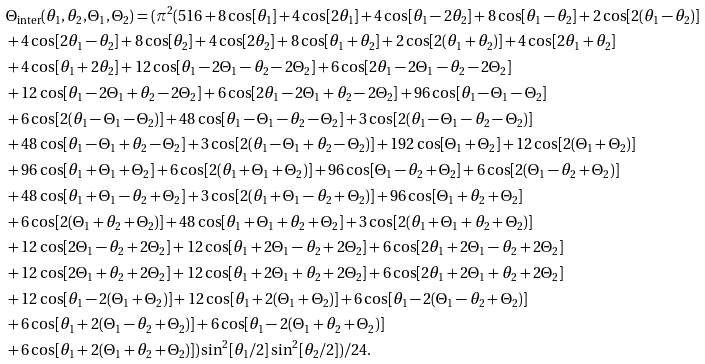Convert formula to latex. <formula><loc_0><loc_0><loc_500><loc_500>& { \Theta } _ { \text {inter} } ( \theta _ { 1 } , \theta _ { 2 } , \Theta _ { 1 } , \Theta _ { 2 } ) = ( \pi ^ { 2 } ( 5 1 6 + 8 \cos [ \theta _ { 1 } ] + 4 \cos [ 2 \theta _ { 1 } ] + 4 \cos [ \theta _ { 1 } - 2 \theta _ { 2 } ] + 8 \cos [ \theta _ { 1 } - \theta _ { 2 } ] + 2 \cos [ 2 ( \theta _ { 1 } - \theta _ { 2 } ) ] \\ & + 4 \cos [ 2 \theta _ { 1 } - \theta _ { 2 } ] + 8 \cos [ \theta _ { 2 } ] + 4 \cos [ 2 \theta _ { 2 } ] + 8 \cos [ \theta _ { 1 } + \theta _ { 2 } ] + 2 \cos [ 2 ( \theta _ { 1 } + \theta _ { 2 } ) ] + 4 \cos [ 2 \theta _ { 1 } + \theta _ { 2 } ] \\ & + 4 \cos [ \theta _ { 1 } + 2 \theta _ { 2 } ] + 1 2 \cos [ \theta _ { 1 } - 2 \Theta _ { 1 } - \theta _ { 2 } - 2 \Theta _ { 2 } ] + 6 \cos [ 2 \theta _ { 1 } - 2 \Theta _ { 1 } - \theta _ { 2 } - 2 \Theta _ { 2 } ] \\ & + 1 2 \cos [ \theta _ { 1 } - 2 \Theta _ { 1 } + \theta _ { 2 } - 2 \Theta _ { 2 } ] + 6 \cos [ 2 \theta _ { 1 } - 2 \Theta _ { 1 } + \theta _ { 2 } - 2 \Theta _ { 2 } ] + 9 6 \cos [ \theta _ { 1 } - \Theta _ { 1 } - \Theta _ { 2 } ] \\ & + 6 \cos [ 2 ( \theta _ { 1 } - \Theta _ { 1 } - \Theta _ { 2 } ) ] + 4 8 \cos [ \theta _ { 1 } - \Theta _ { 1 } - \theta _ { 2 } - \Theta _ { 2 } ] + 3 \cos [ 2 ( \theta _ { 1 } - \Theta _ { 1 } - \theta _ { 2 } - \Theta _ { 2 } ) ] \\ & + 4 8 \cos [ \theta _ { 1 } - \Theta _ { 1 } + \theta _ { 2 } - \Theta _ { 2 } ] + 3 \cos [ 2 ( \theta _ { 1 } - \Theta _ { 1 } + \theta _ { 2 } - \Theta _ { 2 } ) ] + 1 9 2 \cos [ \Theta _ { 1 } + \Theta _ { 2 } ] + 1 2 \cos [ 2 ( \Theta _ { 1 } + \Theta _ { 2 } ) ] \\ & + 9 6 \cos [ \theta _ { 1 } + \Theta _ { 1 } + \Theta _ { 2 } ] + 6 \cos [ 2 ( \theta _ { 1 } + \Theta _ { 1 } + \Theta _ { 2 } ) ] + 9 6 \cos [ \Theta _ { 1 } - \theta _ { 2 } + \Theta _ { 2 } ] + 6 \cos [ 2 ( \Theta _ { 1 } - \theta _ { 2 } + \Theta _ { 2 } ) ] \\ & + 4 8 \cos [ \theta _ { 1 } + \Theta _ { 1 } - \theta _ { 2 } + \Theta _ { 2 } ] + 3 \cos [ 2 ( \theta _ { 1 } + \Theta _ { 1 } - \theta _ { 2 } + \Theta _ { 2 } ) ] + 9 6 \cos [ \Theta _ { 1 } + \theta _ { 2 } + \Theta _ { 2 } ] \\ & + 6 \cos [ 2 ( \Theta _ { 1 } + \theta _ { 2 } + \Theta _ { 2 } ) ] + 4 8 \cos [ \theta _ { 1 } + \Theta _ { 1 } + \theta _ { 2 } + \Theta _ { 2 } ] + 3 \cos [ 2 ( \theta _ { 1 } + \Theta _ { 1 } + \theta _ { 2 } + \Theta _ { 2 } ) ] \\ & + 1 2 \cos [ 2 \Theta _ { 1 } - \theta _ { 2 } + 2 \Theta _ { 2 } ] + 1 2 \cos [ \theta _ { 1 } + 2 \Theta _ { 1 } - \theta _ { 2 } + 2 \Theta _ { 2 } ] + 6 \cos [ 2 \theta _ { 1 } + 2 \Theta _ { 1 } - \theta _ { 2 } + 2 \Theta _ { 2 } ] \\ & + 1 2 \cos [ 2 \Theta _ { 1 } + \theta _ { 2 } + 2 \Theta _ { 2 } ] + 1 2 \cos [ \theta _ { 1 } + 2 \Theta _ { 1 } + \theta _ { 2 } + 2 \Theta _ { 2 } ] + 6 \cos [ 2 \theta _ { 1 } + 2 \Theta _ { 1 } + \theta _ { 2 } + 2 \Theta _ { 2 } ] \\ & + 1 2 \cos [ \theta _ { 1 } - 2 ( \Theta _ { 1 } + \Theta _ { 2 } ) ] + 1 2 \cos [ \theta _ { 1 } + 2 ( \Theta _ { 1 } + \Theta _ { 2 } ) ] + 6 \cos [ \theta _ { 1 } - 2 ( \Theta _ { 1 } - \theta _ { 2 } + \Theta _ { 2 } ) ] \\ & + 6 \cos [ \theta _ { 1 } + 2 ( \Theta _ { 1 } - \theta _ { 2 } + \Theta _ { 2 } ) ] + 6 \cos [ \theta _ { 1 } - 2 ( \Theta _ { 1 } + \theta _ { 2 } + \Theta _ { 2 } ) ] \\ & + 6 \cos [ \theta _ { 1 } + 2 ( \Theta _ { 1 } + \theta _ { 2 } + \Theta _ { 2 } ) ] ) \sin ^ { 2 } [ \theta _ { 1 } / 2 ] \sin ^ { 2 } [ \theta _ { 2 } / 2 ] ) / 2 4 .</formula> 